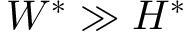Convert formula to latex. <formula><loc_0><loc_0><loc_500><loc_500>W ^ { * } \gg H ^ { * }</formula> 